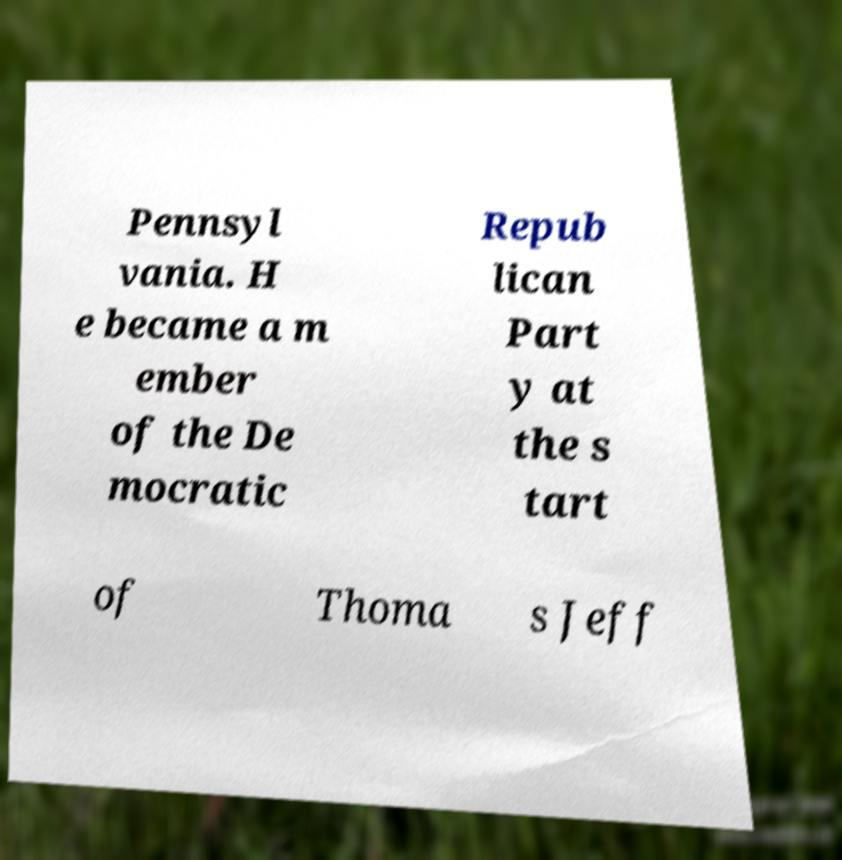I need the written content from this picture converted into text. Can you do that? Pennsyl vania. H e became a m ember of the De mocratic Repub lican Part y at the s tart of Thoma s Jeff 